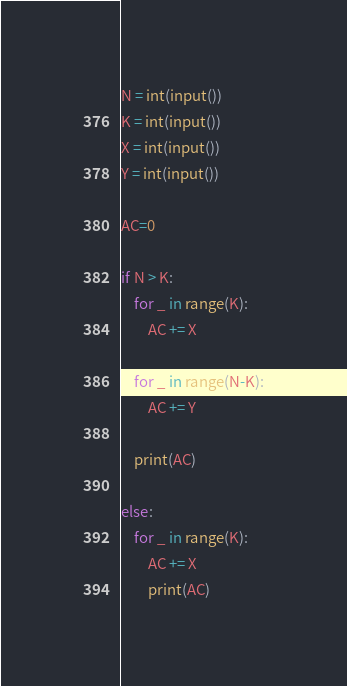<code> <loc_0><loc_0><loc_500><loc_500><_Python_>N = int(input())
K = int(input())
X = int(input())
Y = int(input())

AC=0

if N > K:
    for _ in range(K):
        AC += X
    
    for _ in range(N-K):
        AC += Y

    print(AC)

else:
    for _ in range(K):
        AC += X
        print(AC)</code> 